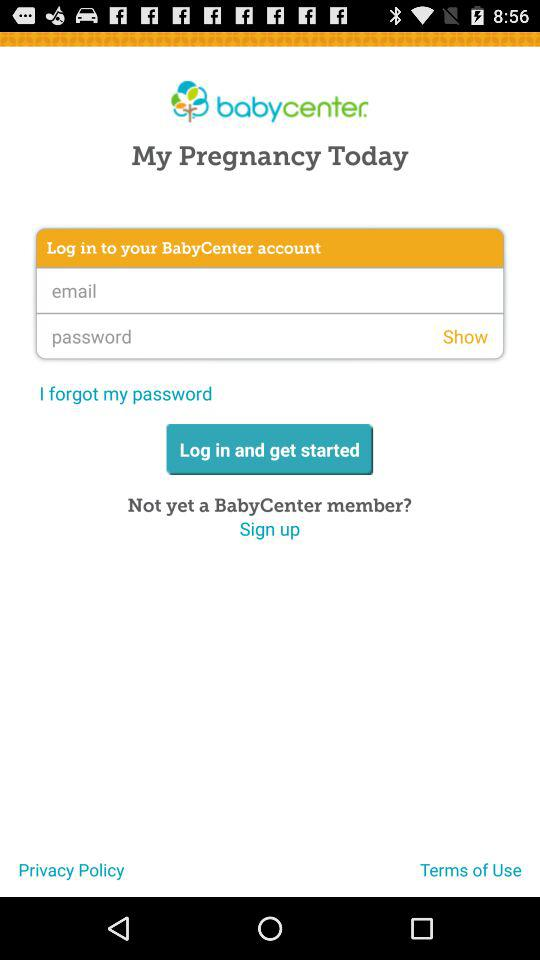How many text input fields are there in the login form?
Answer the question using a single word or phrase. 2 